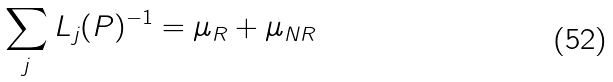Convert formula to latex. <formula><loc_0><loc_0><loc_500><loc_500>\sum _ { j } L _ { j } ( P ) ^ { - 1 } = \mu _ { R } + \mu _ { N R }</formula> 